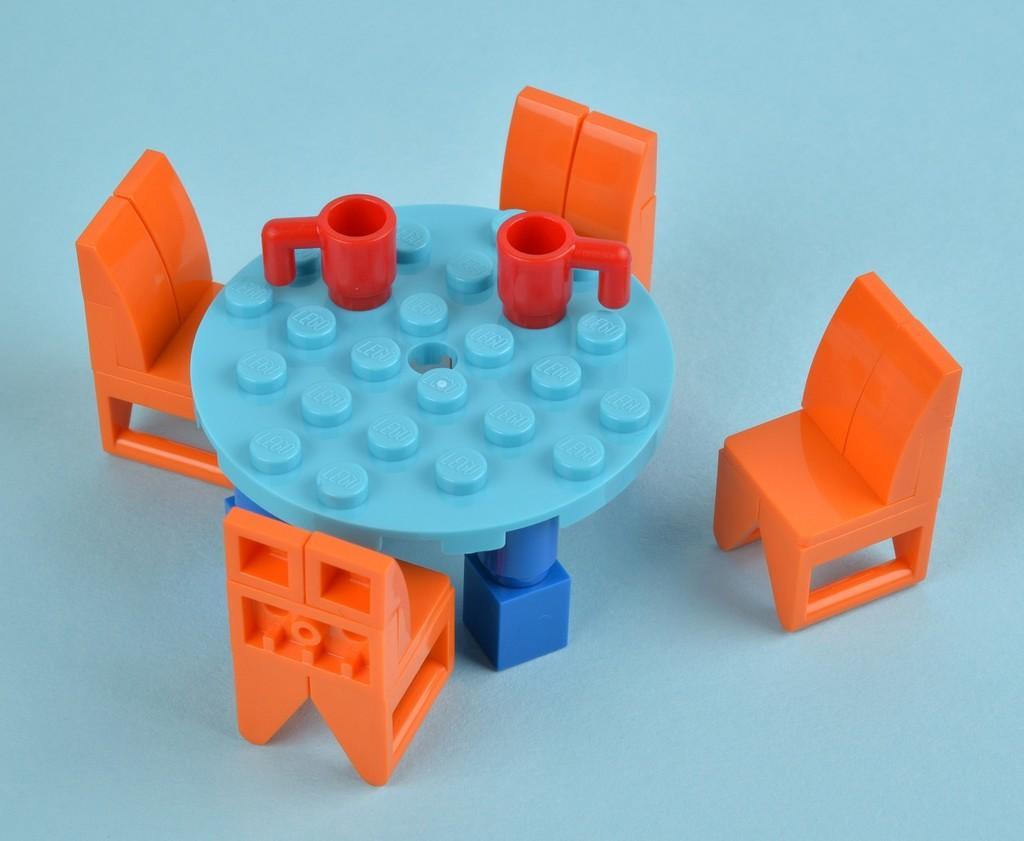Describe this image in one or two sentences. In the middle of the image there is a table, On the table there are two cups. There are four chairs surrounding the table. 